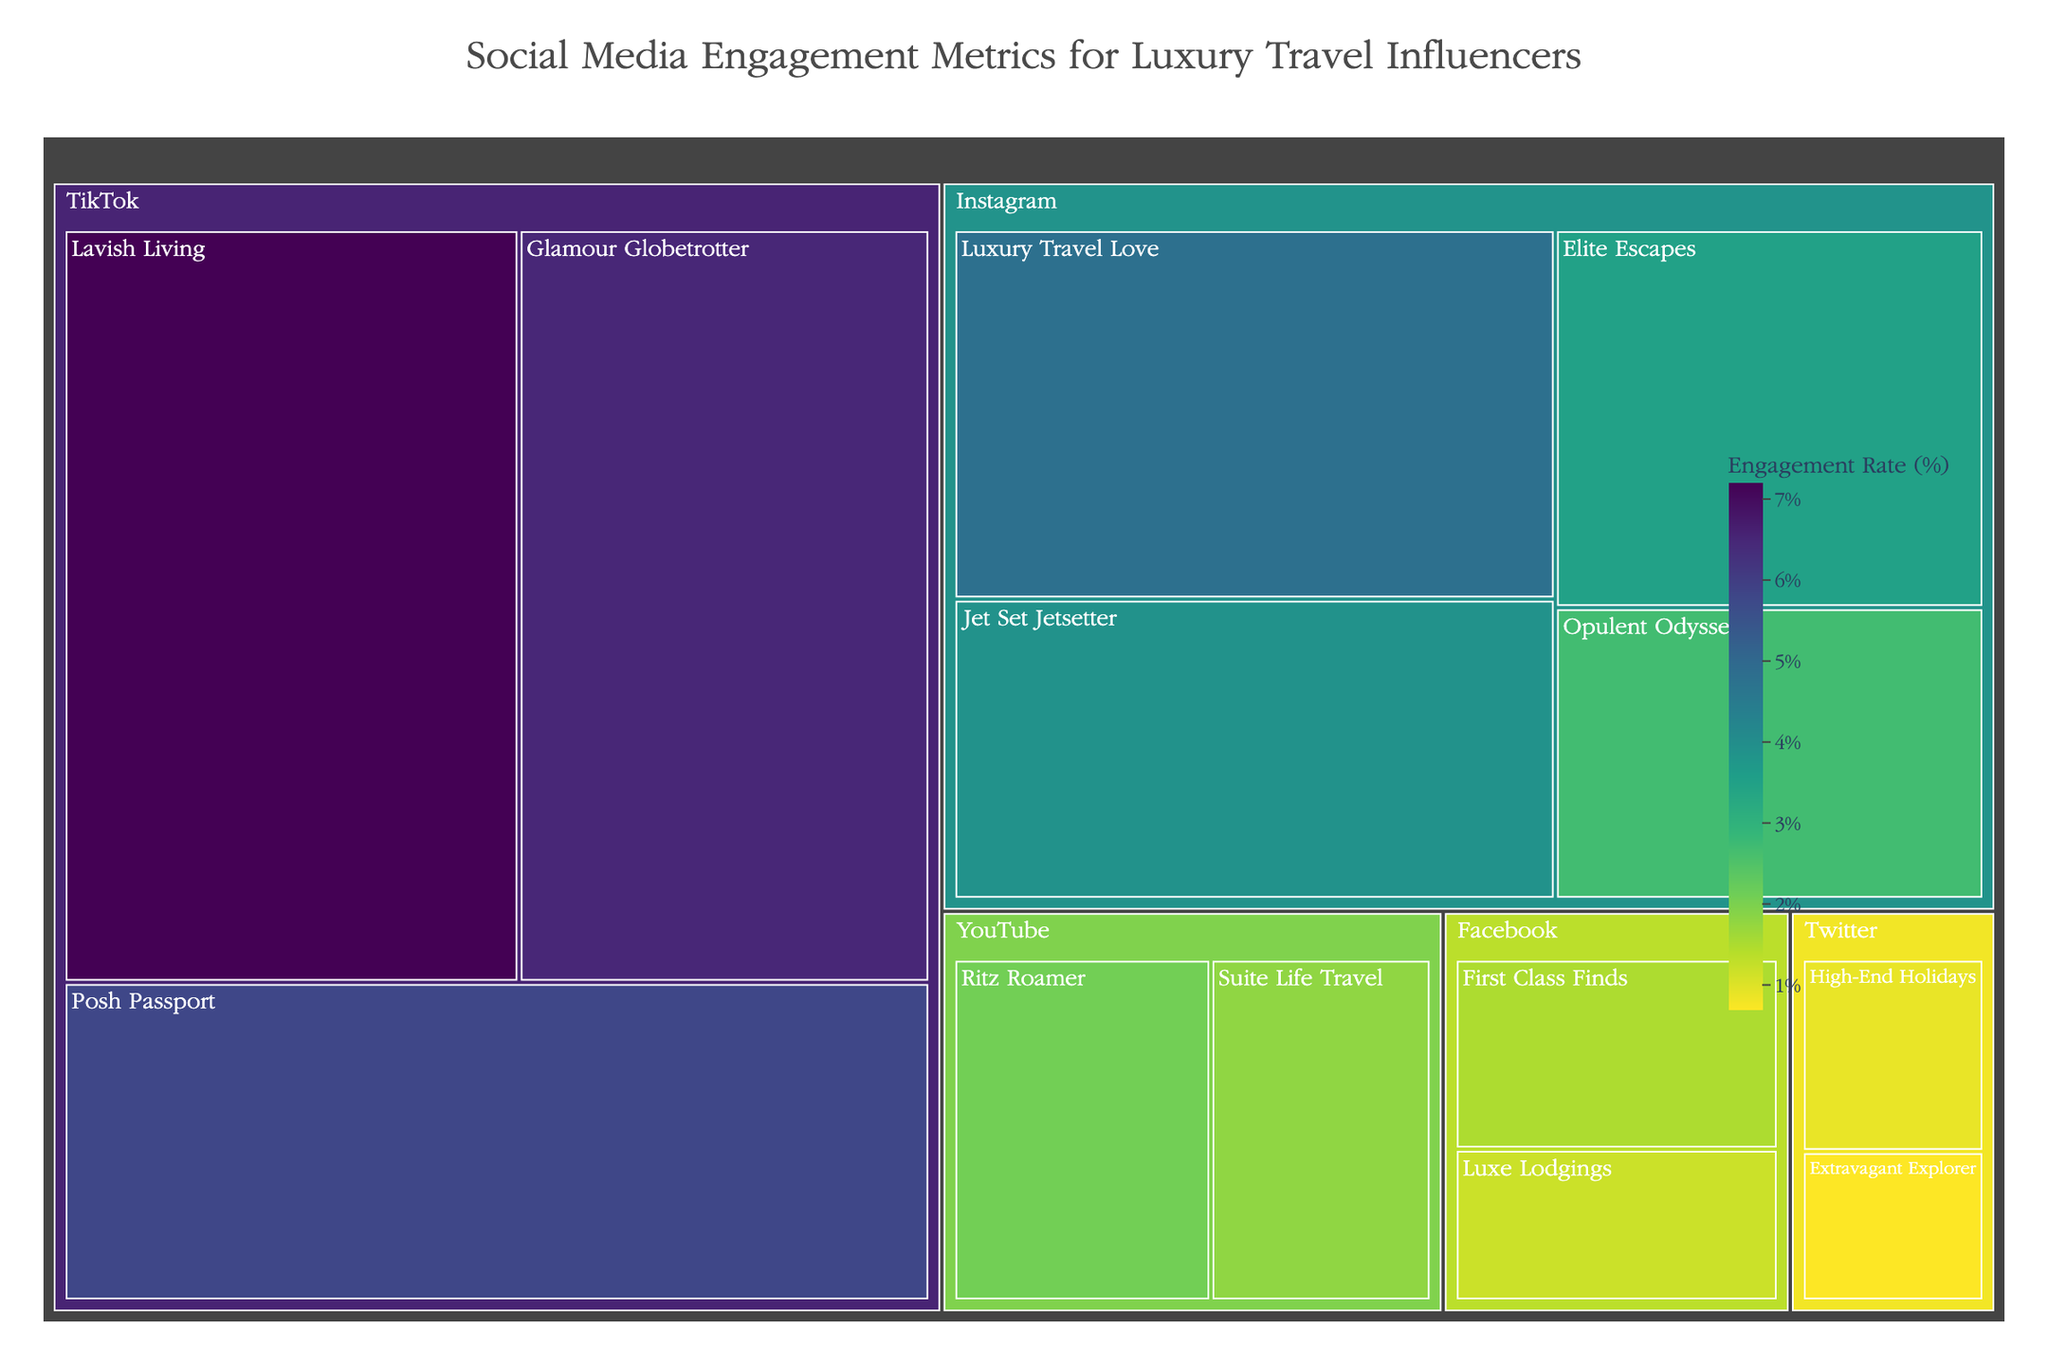How many social media platforms are represented in the treemap? The treemap is divided into sections based on the social media platforms. By counting these sections, we can determine the number of represented platforms.
Answer: 5 What's the engagement rate of "Lavish Living" on TikTok? Locate the section for TikTok, and within it, find the "Lavish Living" influencer. The engagement rate value is displayed within this section.
Answer: 7.2% Which platform has the influencer with the highest engagement rate? Review the engagement rates for each influencer across all platforms. Identify the highest engagement rate and note the corresponding platform.
Answer: TikTok What's the combined engagement rate for "First Class Finds" and "Luxe Lodgings" on Facebook? Locate each influencer under the Facebook platform and sum their engagement rates: 1.5 (First Class Finds) + 1.2 (Luxe Lodgings).
Answer: 2.7% Compare the engagement rates between "Elite Escapes" and "Opulent Odysseys" on Instagram. Who has a higher rate and by how much? Locate "Elite Escapes" and "Opulent Odysseys" under Instagram. Subtract the engagement rate of "Opulent Odysseys" from "Elite Escapes": 3.5 - 2.7.
Answer: Elite Escapes by 0.8% Which influencer has the lowest engagement rate on the treemap? Review all engagement rates in the treemap and identify the smallest value. Note the corresponding influencer.
Answer: Extravagant Explorer Is there a platform where all influencers have an engagement rate below 3%? Check each platform and see if all influencers listed under it have engagement rates below 3%.
Answer: Yes, YouTube and Facebook How does the engagement rate of "Jet Set Jetsetter" on Instagram compare to "Glamour Globetrotter" on TikTok? Compare the engagement rates of both influencers: "Jet Set Jetsetter" has 3.9%, and "Glamour Globetrotter" has 6.5%. Determine which is higher and by how much.
Answer: Glamour Globetrotter by 2.6% What is the average engagement rate of influencers on Instagram? Add the engagement rates of all Instagram influencers and divide by the number of influencers: (4.8 + 3.9 + 3.5 + 2.7) / 4.
Answer: 3.725% How many influencers have an engagement rate above 5%? Count the number of influencers across all platforms whose engagement rates exceed 5%.
Answer: 3 